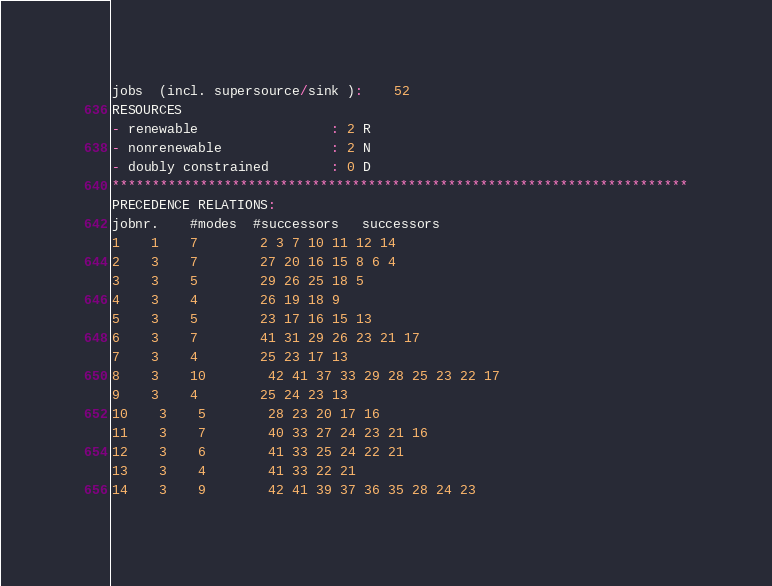Convert code to text. <code><loc_0><loc_0><loc_500><loc_500><_ObjectiveC_>jobs  (incl. supersource/sink ):	52
RESOURCES
- renewable                 : 2 R
- nonrenewable              : 2 N
- doubly constrained        : 0 D
************************************************************************
PRECEDENCE RELATIONS:
jobnr.    #modes  #successors   successors
1	1	7		2 3 7 10 11 12 14 
2	3	7		27 20 16 15 8 6 4 
3	3	5		29 26 25 18 5 
4	3	4		26 19 18 9 
5	3	5		23 17 16 15 13 
6	3	7		41 31 29 26 23 21 17 
7	3	4		25 23 17 13 
8	3	10		42 41 37 33 29 28 25 23 22 17 
9	3	4		25 24 23 13 
10	3	5		28 23 20 17 16 
11	3	7		40 33 27 24 23 21 16 
12	3	6		41 33 25 24 22 21 
13	3	4		41 33 22 21 
14	3	9		42 41 39 37 36 35 28 24 23 </code> 